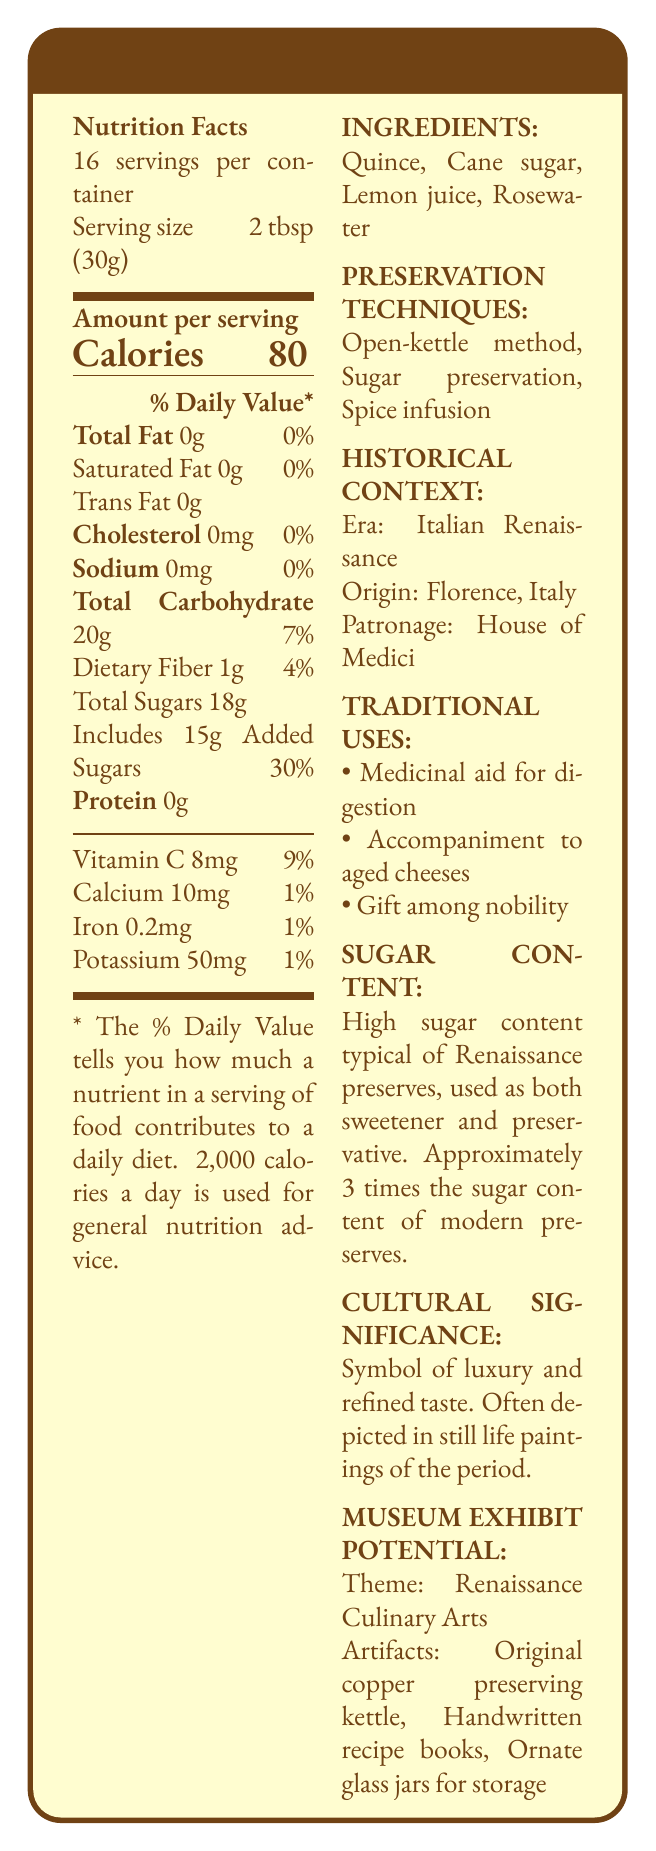what is the serving size? The serving size is explicitly mentioned in the Nutrition Facts section as 2 tablespoons (30g).
Answer: 2 tablespoons (30g) how many calories are in one serving? The Nutrition Facts section lists the amount of calories per serving as 80.
Answer: 80 list the ingredients in Medici's Royal Quince Preserve The ingredients are listed under the INGREDIENTS section of the document.
Answer: Quince, Cane sugar, Lemon juice, Rosewater which preservation techniques are used? The preservation techniques are detailed under the PRESERVATION TECHNIQUES section.
Answer: Open-kettle method, Sugar preservation, Spice infusion what is the historical origin of Medici's Royal Quince Preserve? The document states that the origin is Florence, Italy, in the HISTORICAL CONTEXT section.
Answer: Florence, Italy what is the serving size? The serving size is explicitly mentioned in the Nutrition Facts section as 2 tablespoons (30g).
Answer: 2 tablespoons (30g) how many calories are in one serving? The Nutrition Facts section lists the amount of calories per serving as 80.
Answer: 80 list the ingredients in Medici's Royal Quince Preserve The ingredients are listed under the INGREDIENTS section of the document.
Answer: Quince, Cane sugar, Lemon juice, Rosewater which preservation techniques are used? The preservation techniques are detailed under the PRESERVATION TECHNIQUES section.
Answer: Open-kettle method, Sugar preservation, Spice infusion what is the historical origin of Medici's Royal Quince Preserve? The document states that the origin is Florence, Italy, in the HISTORICAL CONTEXT section.
Answer: Florence, Italy  The traditional uses listed are medicinal aid for digestion, accompaniment to aged cheeses, and gift among nobility. Main course for dinner is not mentioned.
Answer: 3 how is the high sugar content explained in the Renaissance context?
I. Used as a sweetener
II. Used as a preservative
III. Used as a coloring agent
IV. Used as a medicinal ingredient The high sugar content is explained as being used both as a sweetener and a preservative.
Answer: I & II Does Medici's Royal Quince Preserve contain any trans fat? The Nutrition Facts section explicitly states that there is 0g of trans fat.
Answer: No true or false: Rosewater is one of the ingredients in Medici's Royal Quince Preserve. Rosewater is listed as one of the ingredients in the INGREDIENTS section.
Answer: True briefly describe the main theme and potential artifact exhibits for a museum exhibit based on this document According to the MUSEUM EXHIBIT POTENTIAL section, the theme is Renaissance Culinary Arts with suggested artifacts including a copper preserving kettle, recipe books, and glass jars.
Answer: The main theme of the museum exhibit would be "Renaissance Culinary Arts." Potential artifacts could include an original copper preserving kettle, handwritten recipe books, and ornate glass jars for storage. how was sugar content in Renaissance preserves compared to modern-day preserves? The document indicates that the sugar content in Renaissance preserves was approximately 3 times higher than that of modern preserves.
Answer: Approximately 3 times higher what is the annual revenue generated from selling Medici's Royal Quince Preserve? The document does not provide any data regarding sales, pricing, or revenue, so this question cannot be answered based on the given information.
Answer: Not enough information 